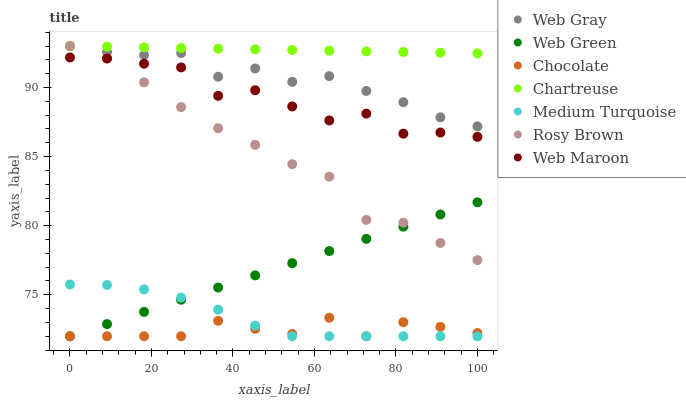Does Chocolate have the minimum area under the curve?
Answer yes or no. Yes. Does Chartreuse have the maximum area under the curve?
Answer yes or no. Yes. Does Rosy Brown have the minimum area under the curve?
Answer yes or no. No. Does Rosy Brown have the maximum area under the curve?
Answer yes or no. No. Is Web Green the smoothest?
Answer yes or no. Yes. Is Web Maroon the roughest?
Answer yes or no. Yes. Is Rosy Brown the smoothest?
Answer yes or no. No. Is Rosy Brown the roughest?
Answer yes or no. No. Does Web Green have the lowest value?
Answer yes or no. Yes. Does Rosy Brown have the lowest value?
Answer yes or no. No. Does Chartreuse have the highest value?
Answer yes or no. Yes. Does Web Maroon have the highest value?
Answer yes or no. No. Is Chocolate less than Web Gray?
Answer yes or no. Yes. Is Chartreuse greater than Web Green?
Answer yes or no. Yes. Does Rosy Brown intersect Web Gray?
Answer yes or no. Yes. Is Rosy Brown less than Web Gray?
Answer yes or no. No. Is Rosy Brown greater than Web Gray?
Answer yes or no. No. Does Chocolate intersect Web Gray?
Answer yes or no. No. 